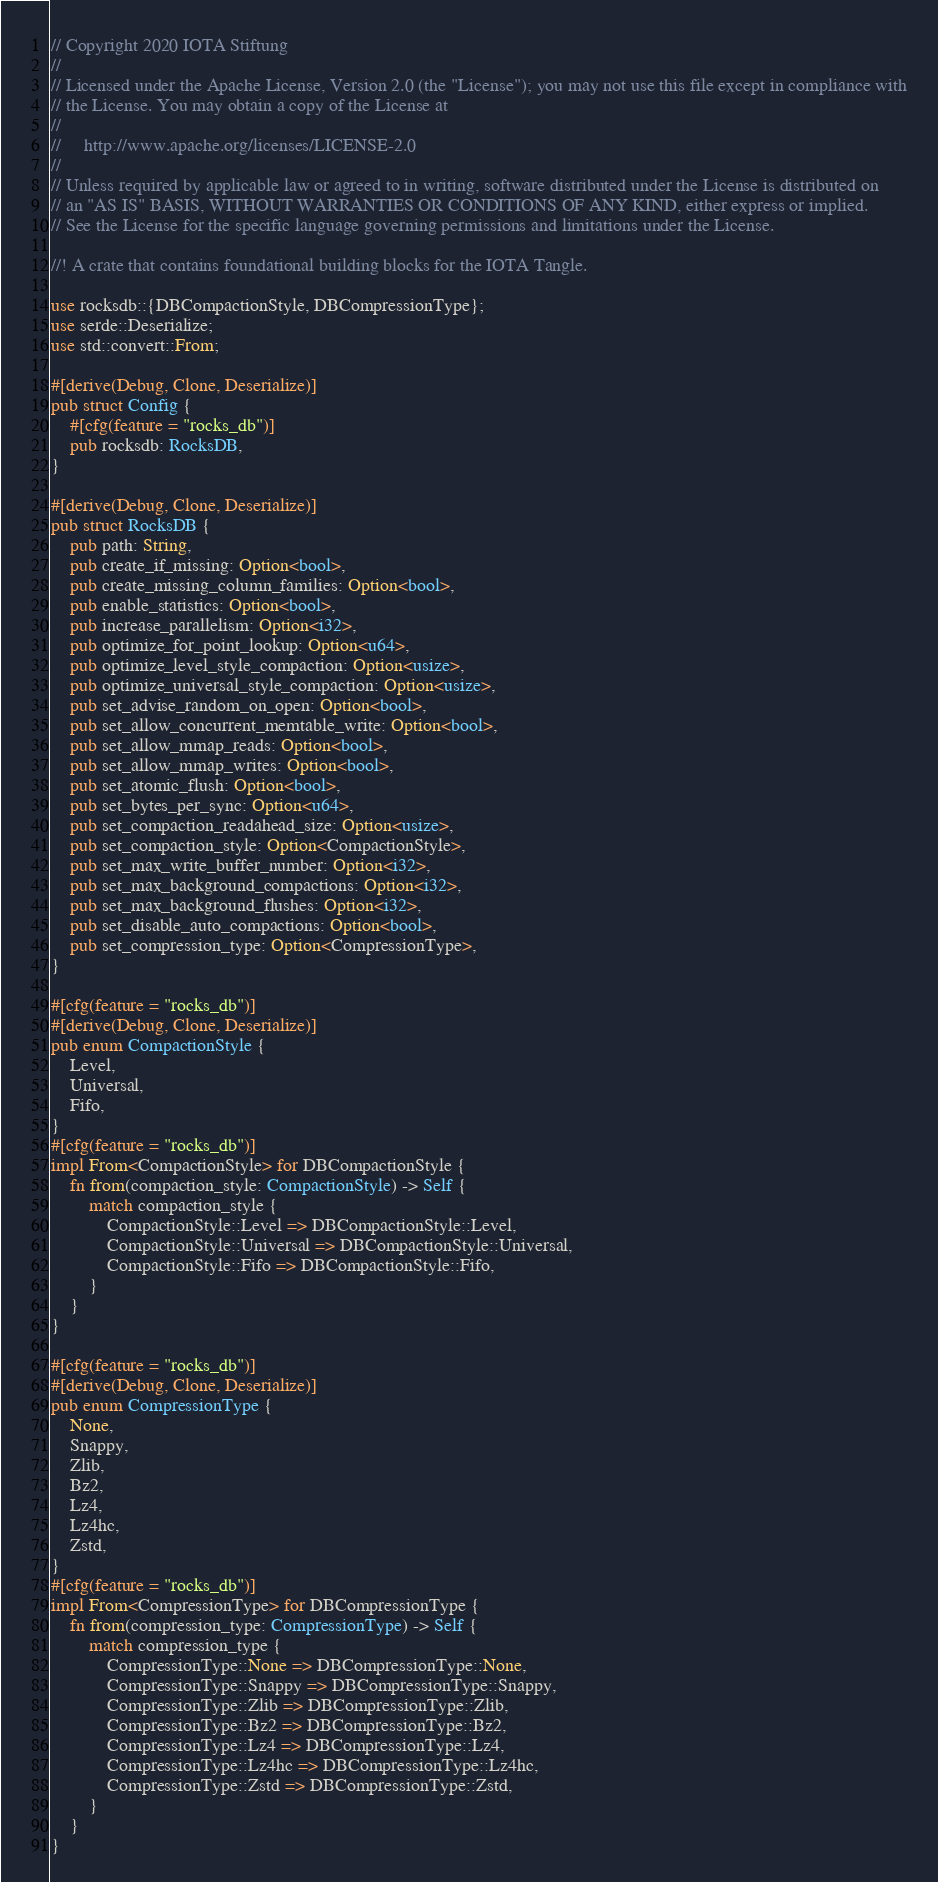<code> <loc_0><loc_0><loc_500><loc_500><_Rust_>// Copyright 2020 IOTA Stiftung
//
// Licensed under the Apache License, Version 2.0 (the "License"); you may not use this file except in compliance with
// the License. You may obtain a copy of the License at
//
//     http://www.apache.org/licenses/LICENSE-2.0
//
// Unless required by applicable law or agreed to in writing, software distributed under the License is distributed on
// an "AS IS" BASIS, WITHOUT WARRANTIES OR CONDITIONS OF ANY KIND, either express or implied.
// See the License for the specific language governing permissions and limitations under the License.

//! A crate that contains foundational building blocks for the IOTA Tangle.

use rocksdb::{DBCompactionStyle, DBCompressionType};
use serde::Deserialize;
use std::convert::From;

#[derive(Debug, Clone, Deserialize)]
pub struct Config {
    #[cfg(feature = "rocks_db")]
    pub rocksdb: RocksDB,
}

#[derive(Debug, Clone, Deserialize)]
pub struct RocksDB {
    pub path: String,
    pub create_if_missing: Option<bool>,
    pub create_missing_column_families: Option<bool>,
    pub enable_statistics: Option<bool>,
    pub increase_parallelism: Option<i32>,
    pub optimize_for_point_lookup: Option<u64>,
    pub optimize_level_style_compaction: Option<usize>,
    pub optimize_universal_style_compaction: Option<usize>,
    pub set_advise_random_on_open: Option<bool>,
    pub set_allow_concurrent_memtable_write: Option<bool>,
    pub set_allow_mmap_reads: Option<bool>,
    pub set_allow_mmap_writes: Option<bool>,
    pub set_atomic_flush: Option<bool>,
    pub set_bytes_per_sync: Option<u64>,
    pub set_compaction_readahead_size: Option<usize>,
    pub set_compaction_style: Option<CompactionStyle>,
    pub set_max_write_buffer_number: Option<i32>,
    pub set_max_background_compactions: Option<i32>,
    pub set_max_background_flushes: Option<i32>,
    pub set_disable_auto_compactions: Option<bool>,
    pub set_compression_type: Option<CompressionType>,
}

#[cfg(feature = "rocks_db")]
#[derive(Debug, Clone, Deserialize)]
pub enum CompactionStyle {
    Level,
    Universal,
    Fifo,
}
#[cfg(feature = "rocks_db")]
impl From<CompactionStyle> for DBCompactionStyle {
    fn from(compaction_style: CompactionStyle) -> Self {
        match compaction_style {
            CompactionStyle::Level => DBCompactionStyle::Level,
            CompactionStyle::Universal => DBCompactionStyle::Universal,
            CompactionStyle::Fifo => DBCompactionStyle::Fifo,
        }
    }
}

#[cfg(feature = "rocks_db")]
#[derive(Debug, Clone, Deserialize)]
pub enum CompressionType {
    None,
    Snappy,
    Zlib,
    Bz2,
    Lz4,
    Lz4hc,
    Zstd,
}
#[cfg(feature = "rocks_db")]
impl From<CompressionType> for DBCompressionType {
    fn from(compression_type: CompressionType) -> Self {
        match compression_type {
            CompressionType::None => DBCompressionType::None,
            CompressionType::Snappy => DBCompressionType::Snappy,
            CompressionType::Zlib => DBCompressionType::Zlib,
            CompressionType::Bz2 => DBCompressionType::Bz2,
            CompressionType::Lz4 => DBCompressionType::Lz4,
            CompressionType::Lz4hc => DBCompressionType::Lz4hc,
            CompressionType::Zstd => DBCompressionType::Zstd,
        }
    }
}
</code> 